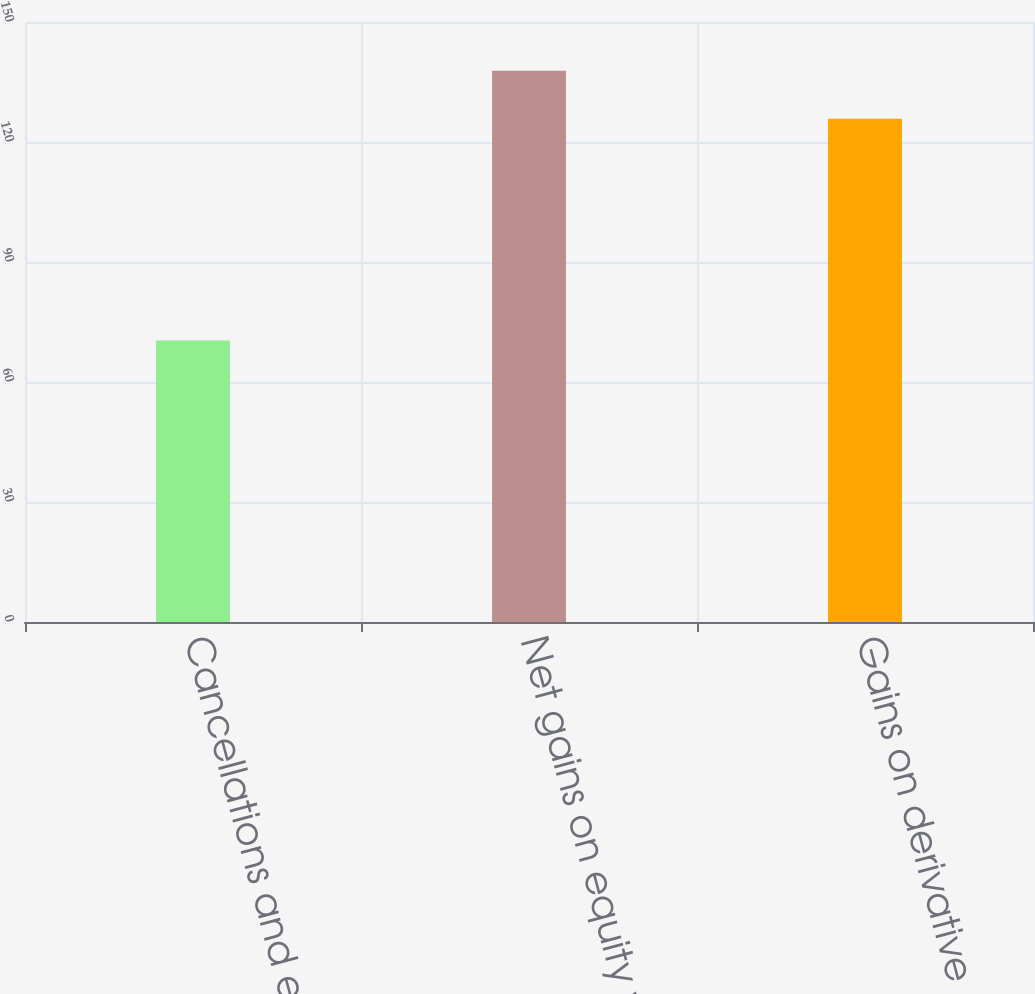Convert chart. <chart><loc_0><loc_0><loc_500><loc_500><bar_chart><fcel>Cancellations and expirations<fcel>Net gains on equity warrant<fcel>Gains on derivative<nl><fcel>70.4<fcel>137.8<fcel>125.8<nl></chart> 